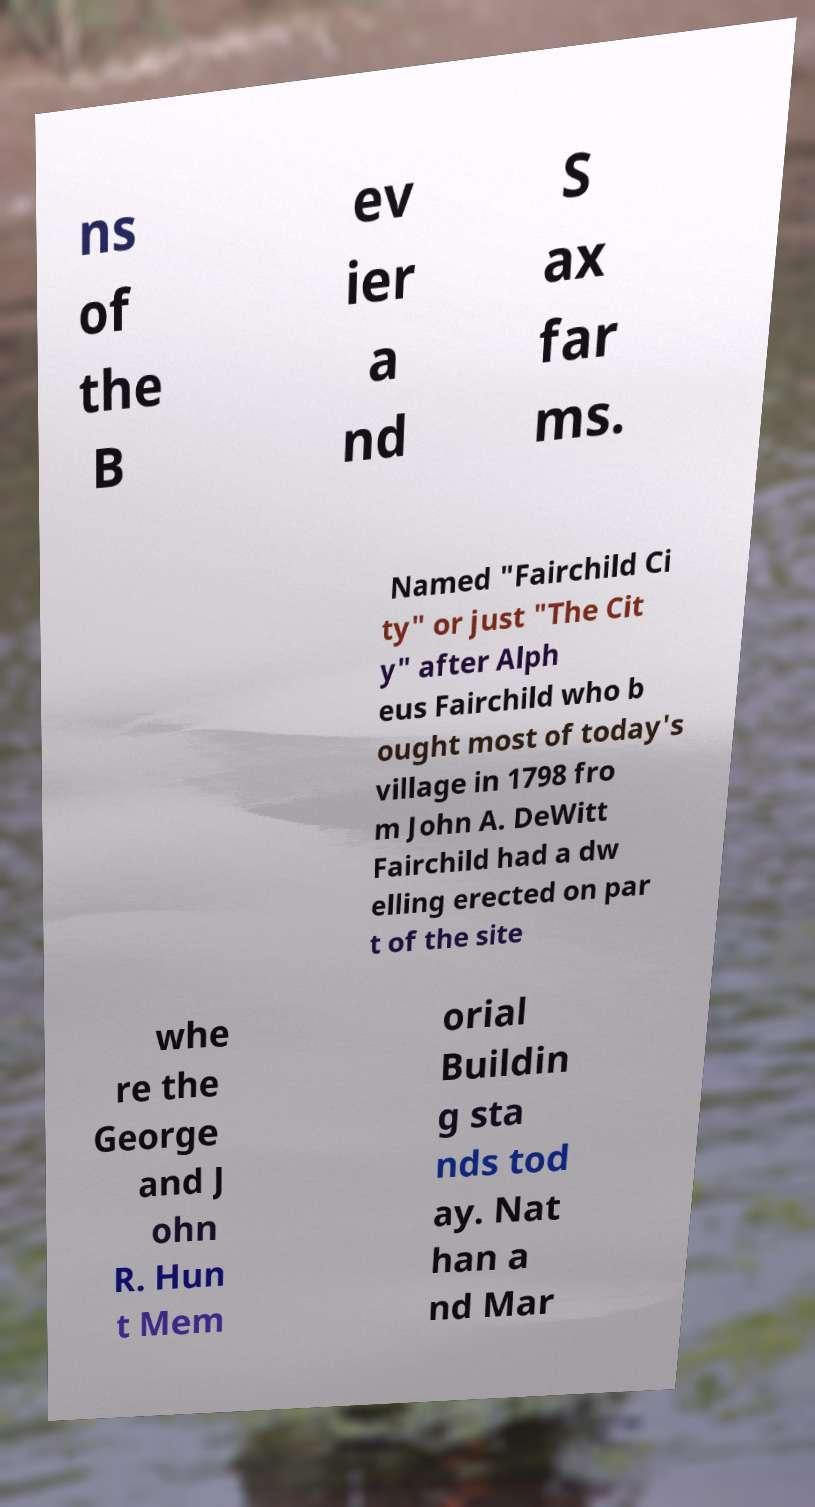There's text embedded in this image that I need extracted. Can you transcribe it verbatim? ns of the B ev ier a nd S ax far ms. Named "Fairchild Ci ty" or just "The Cit y" after Alph eus Fairchild who b ought most of today's village in 1798 fro m John A. DeWitt Fairchild had a dw elling erected on par t of the site whe re the George and J ohn R. Hun t Mem orial Buildin g sta nds tod ay. Nat han a nd Mar 